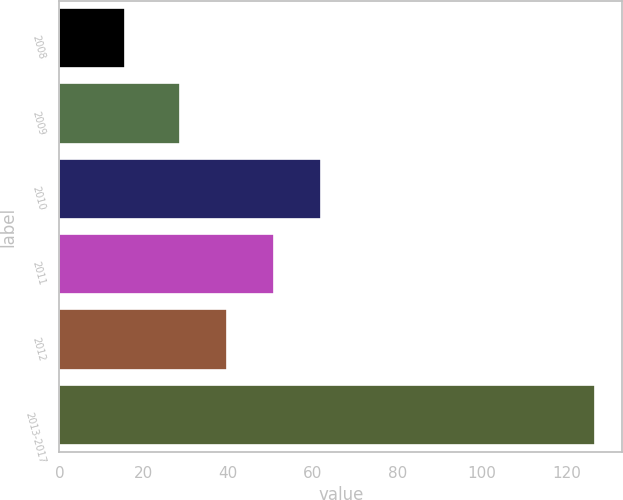<chart> <loc_0><loc_0><loc_500><loc_500><bar_chart><fcel>2008<fcel>2009<fcel>2010<fcel>2011<fcel>2012<fcel>2013-2017<nl><fcel>15.6<fcel>28.6<fcel>61.99<fcel>50.86<fcel>39.73<fcel>126.9<nl></chart> 